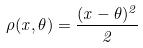<formula> <loc_0><loc_0><loc_500><loc_500>\rho ( x , \theta ) = \frac { ( x - \theta ) ^ { 2 } } { 2 }</formula> 